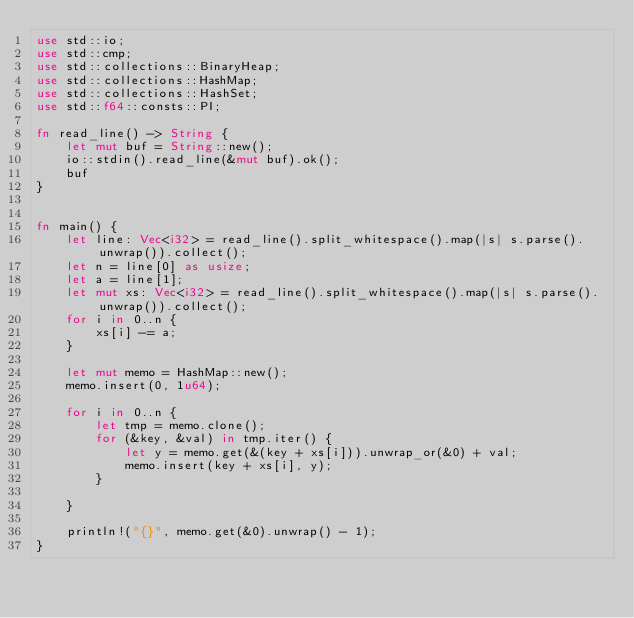<code> <loc_0><loc_0><loc_500><loc_500><_Rust_>use std::io;
use std::cmp;
use std::collections::BinaryHeap;
use std::collections::HashMap;
use std::collections::HashSet;
use std::f64::consts::PI;

fn read_line() -> String {
    let mut buf = String::new();
    io::stdin().read_line(&mut buf).ok();
    buf
}


fn main() {
    let line: Vec<i32> = read_line().split_whitespace().map(|s| s.parse().unwrap()).collect();
    let n = line[0] as usize;
    let a = line[1];
    let mut xs: Vec<i32> = read_line().split_whitespace().map(|s| s.parse().unwrap()).collect();
    for i in 0..n {
        xs[i] -= a;
    }

    let mut memo = HashMap::new();
    memo.insert(0, 1u64);

    for i in 0..n {
        let tmp = memo.clone();
        for (&key, &val) in tmp.iter() {
            let y = memo.get(&(key + xs[i])).unwrap_or(&0) + val;
            memo.insert(key + xs[i], y);
        }

    }

    println!("{}", memo.get(&0).unwrap() - 1);
}
</code> 